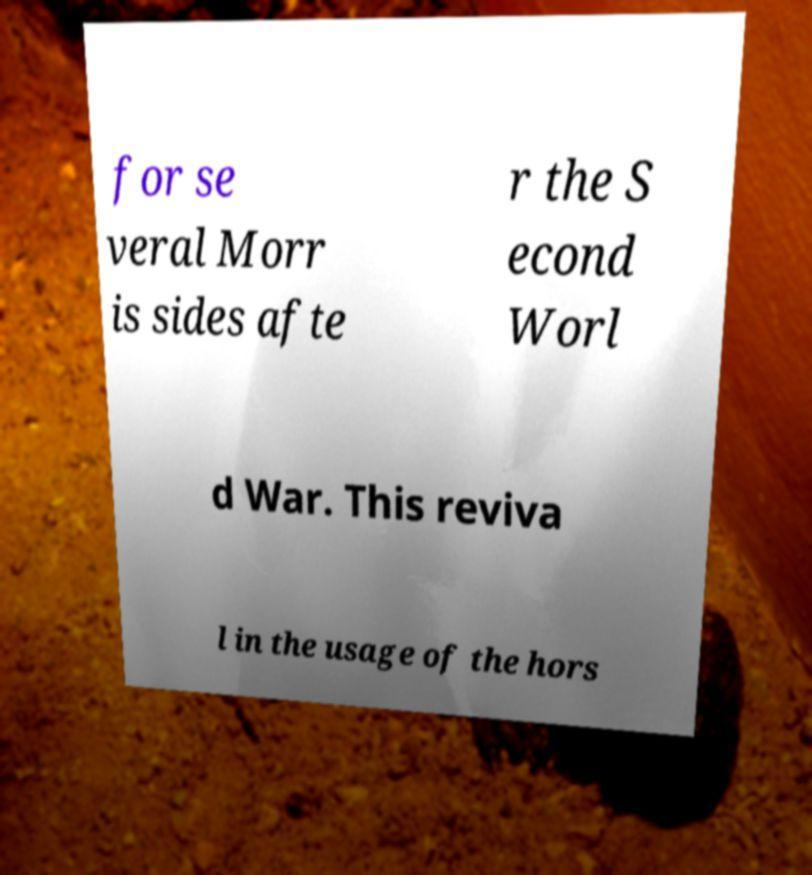Could you extract and type out the text from this image? for se veral Morr is sides afte r the S econd Worl d War. This reviva l in the usage of the hors 